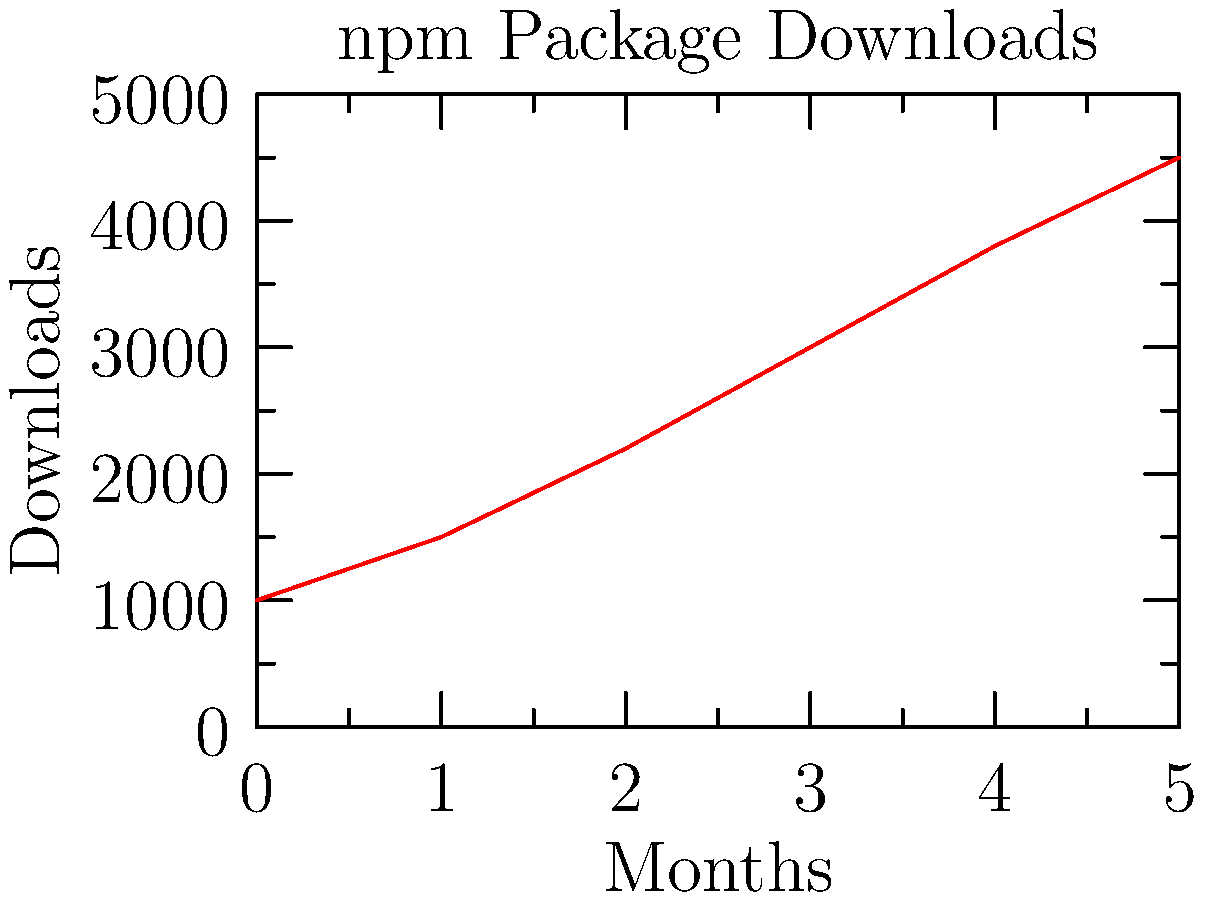Given the line graph representing the download statistics of an npm package over 6 months, what is the approximate average month-over-month growth rate in downloads? To calculate the average month-over-month growth rate:

1. Calculate total growth: Final value (4500) - Initial value (1000) = 3500
2. Number of periods: 6 months - 1 = 5 periods
3. Average growth per period: 3500 / 5 = 700 downloads/month
4. Average growth rate: (700 / 1000) * 100 = 70%

Therefore, the approximate average month-over-month growth rate is 70%.
Answer: 70% 